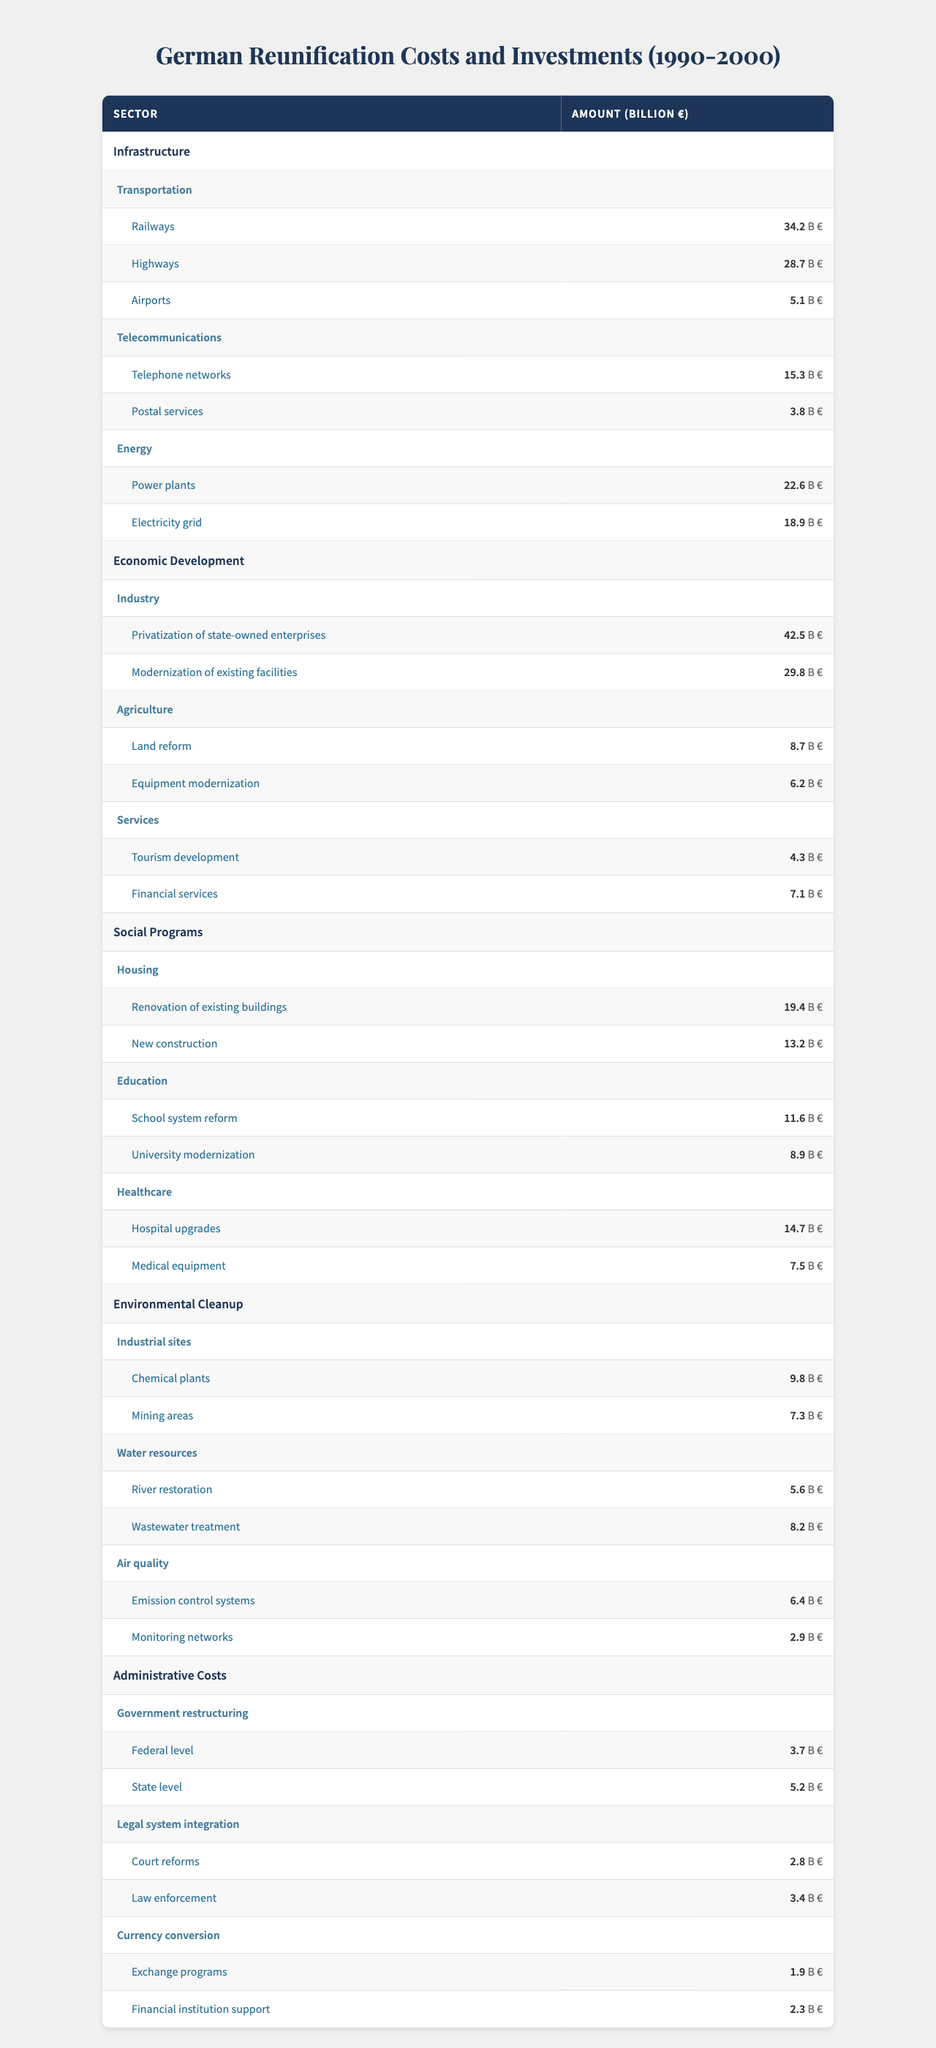What is the total investment in infrastructure? To find the total investment in infrastructure, we sum the values: Railways (34.2) + Highways (28.7) + Airports (5.1) + Telephone networks (15.3) + Postal services (3.8) + Power plants (22.6) + Electricity grid (18.9) = 128.6
Answer: 128.6 What sector had the highest individual investment? The highest individual investment is in "Privatization of state-owned enterprises" amounting to 42.5 billion euros under the Economic Development sector.
Answer: 42.5 billion euros Which subsector under Social Programs had the least investment? Under Social Programs, the subsector with the least investment is Services, specifically "Tourism development," which amounts to 4.3 billion euros.
Answer: 4.3 billion euros What is the total cost of environmental cleanup efforts? The total cost of environmental cleanup is calculated by summing all categories: Chemical plants (9.8) + Mining areas (7.3) + River restoration (5.6) + Wastewater treatment (8.2) + Emission control systems (6.4) + Monitoring networks (2.9) = 40.2
Answer: 40.2 Was more funding allocated to Social Programs than to Administrative Costs? We compare the total for Social Programs (sum of Housing, Education, and Healthcare) which equals 19.4 + 13.2 + 14.7 = 47.3 billion euros, to Administrative Costs which equals 3.7 + 5.2 + 2.8 + 3.4 + 1.9 + 2.3 = 19.3 billion euros. Since 47.3 > 19.3, we can conclude yes, more funding was allocated to Social Programs.
Answer: Yes What is the average investment in each category under Economic Development? The categories under Economic Development are Industry (Privatization: 42.5, Modernization: 29.8), Agriculture (Land reform: 8.7, Equipment: 6.2), and Services (Tourism: 4.3, Financial: 7.1), totaling 98.7. There are 6 categories, so the average is 98.7 / 6 = 16.45
Answer: 16.45 How much more was invested in Transportation compared to Telecommunications? For Transportation, the investment totals 34.2 + 28.7 + 5.1 = 68 billion euros, and for Telecommunications, it totals 15.3 + 3.8 = 19.1 billion euros. The difference is 68 - 19.1 = 48.9 billion euros.
Answer: 48.9 billion euros What percentage of total investments was made in Energy? Energy investments are 22.6 + 18.9 = 41.5 billion euros. The total investments across all sectors is 440.5 billion euros (calculated by summing all data points). The percentage is (41.5 / 440.5) * 100 ≈ 9.42%.
Answer: 9.42% Which category in Environmental Cleanup had the highest individual investment? The highest investment in Environmental Cleanup is for Wastewater treatment at 8.2 billion euros.
Answer: 8.2 billion euros How much was spent on New Construction compared to Hospital Upgrades? New Construction costs 13.2 billion euros and Hospital Upgrades cost 14.7 billion euros. The difference is calculated as 14.7 - 13.2 = 1.5 billion euros.
Answer: 1.5 billion euros Is the total investment in Infrastructure greater than the total investment in Social Programs? Infrastructure totals 128.6 billion euros, while Social Programs total 47.3 billion euros. Since 128.6 > 47.3, we conclude yes, Infrastructure investment is greater.
Answer: Yes 